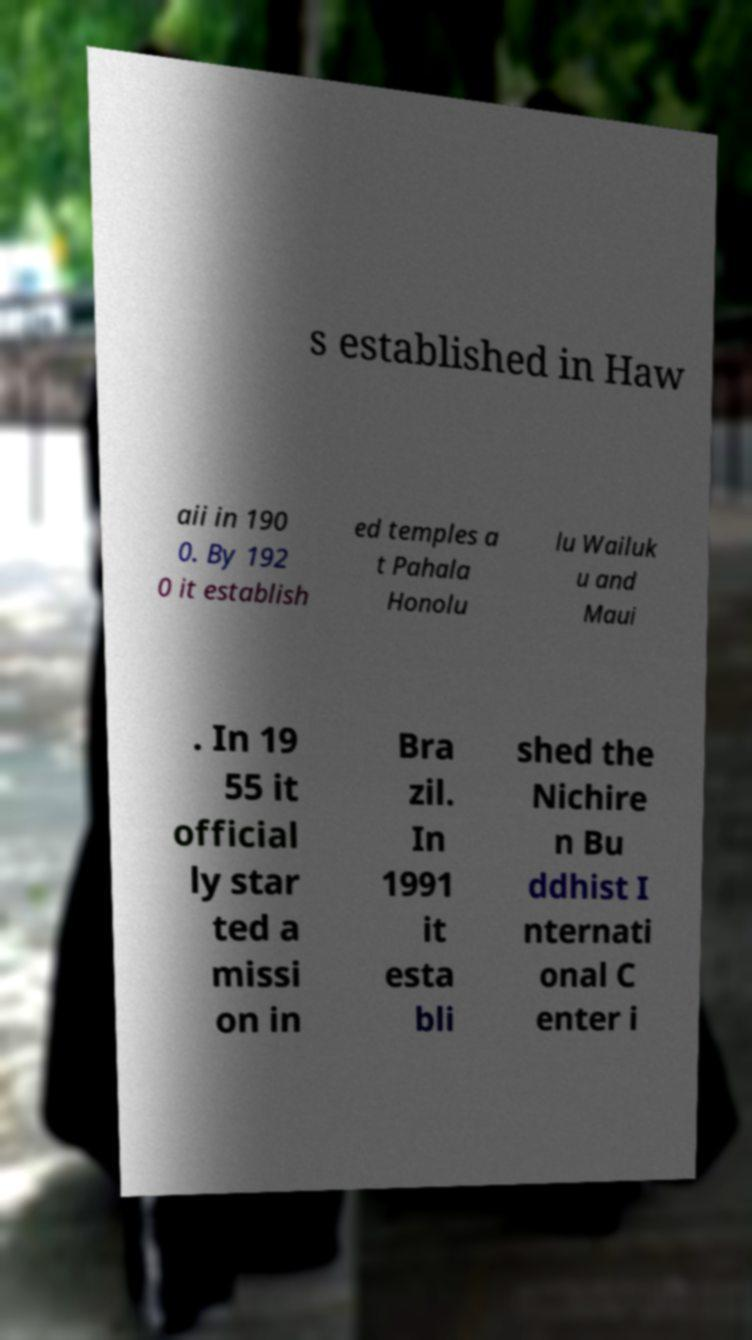There's text embedded in this image that I need extracted. Can you transcribe it verbatim? s established in Haw aii in 190 0. By 192 0 it establish ed temples a t Pahala Honolu lu Wailuk u and Maui . In 19 55 it official ly star ted a missi on in Bra zil. In 1991 it esta bli shed the Nichire n Bu ddhist I nternati onal C enter i 